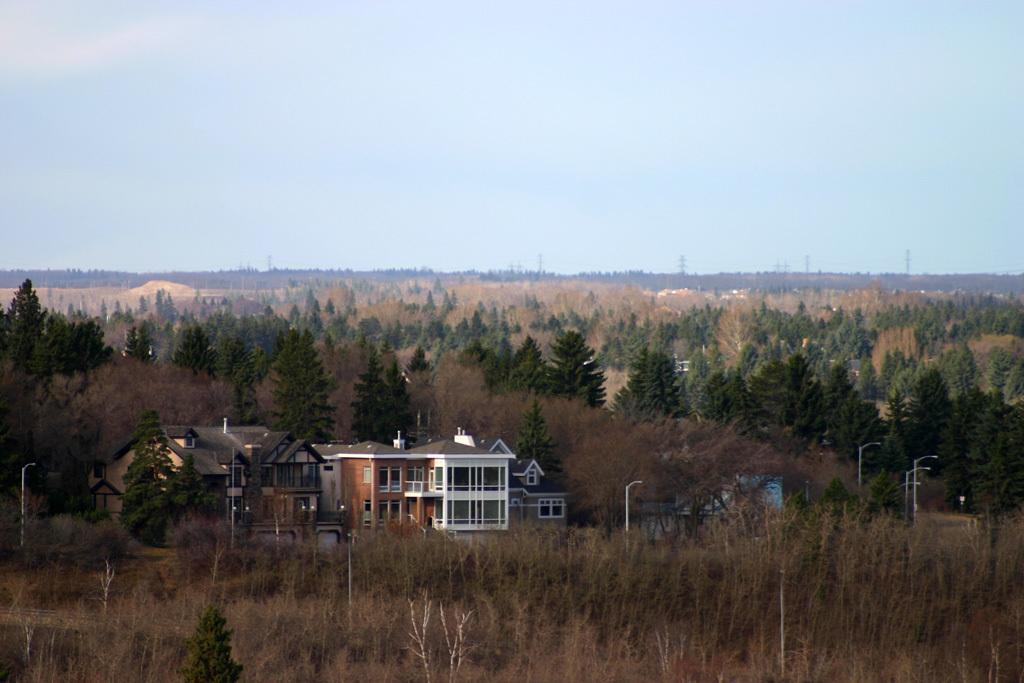Please provide a concise description of this image. There are plants, trees, buildings and poles on the ground. In the background, there are clouds in the sky. 